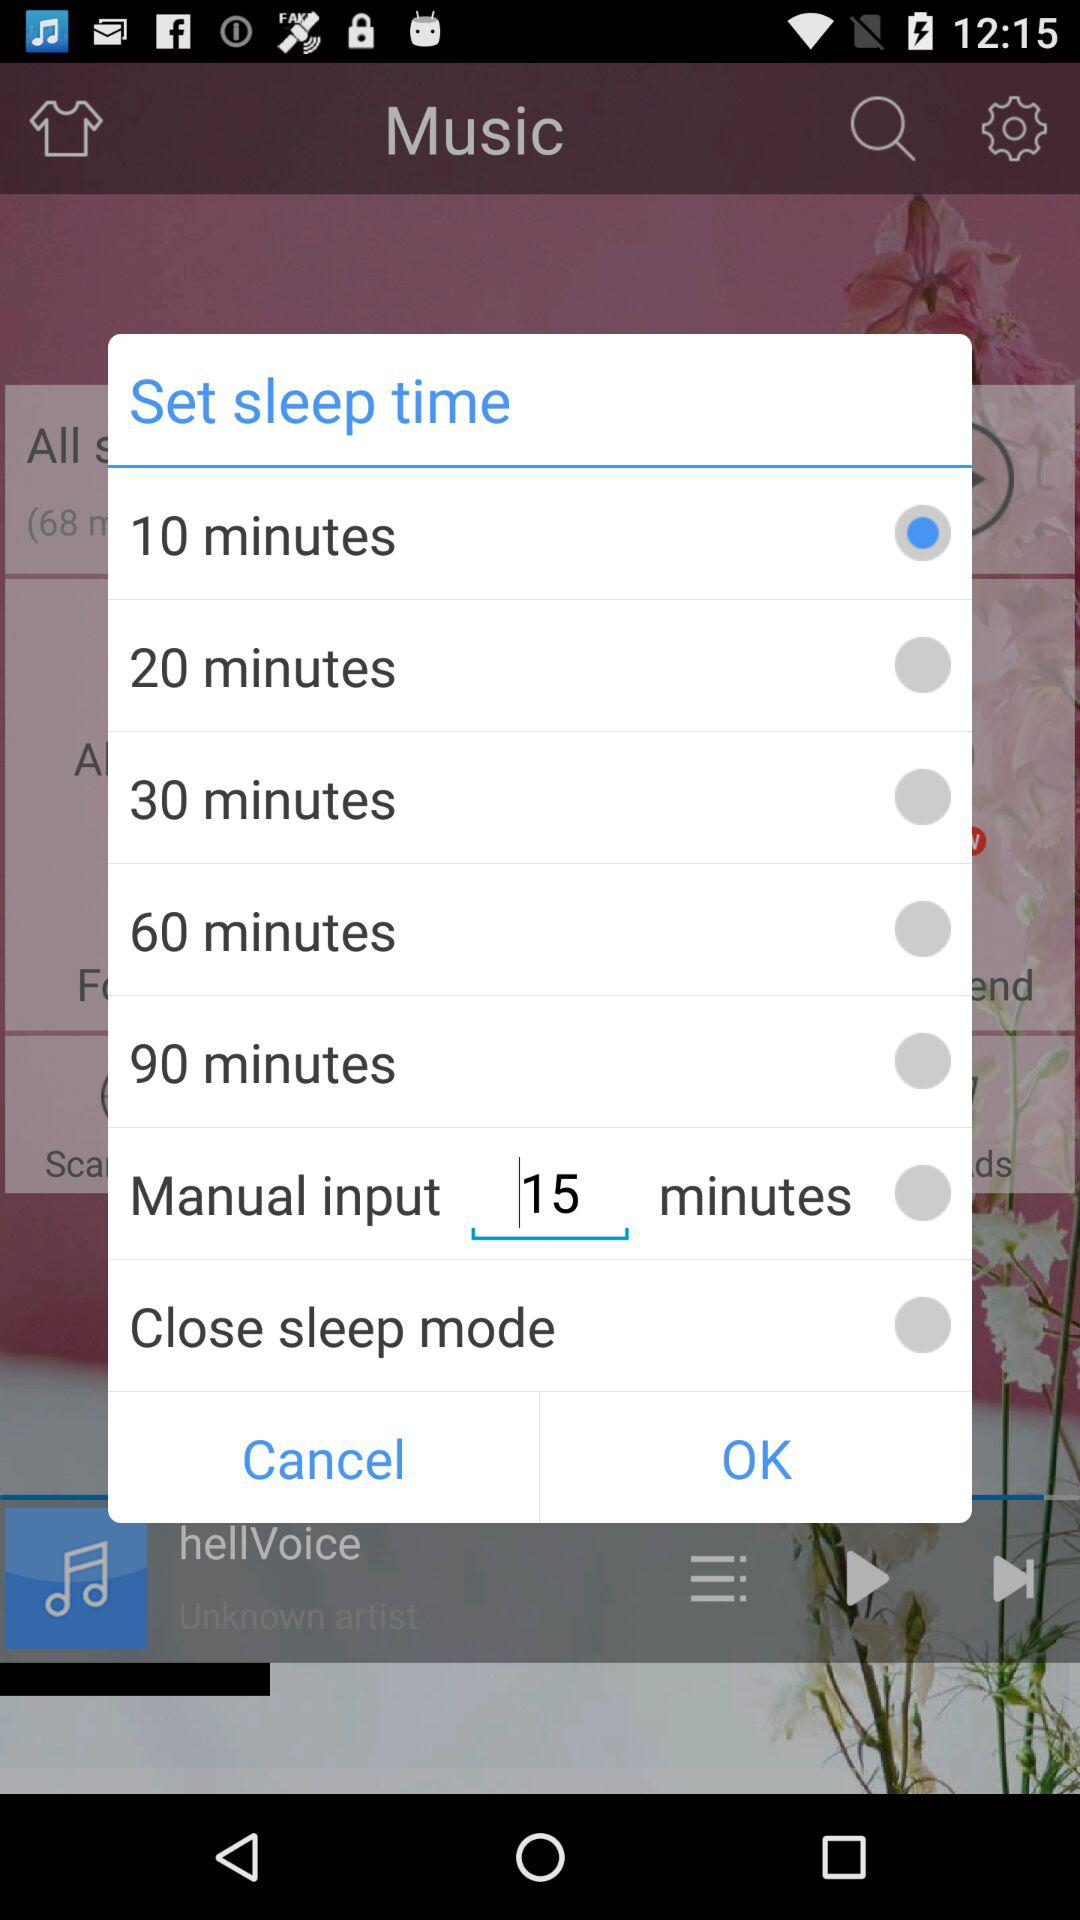Is "20 minutes" selected or not? "20 minutes" is not selected. 